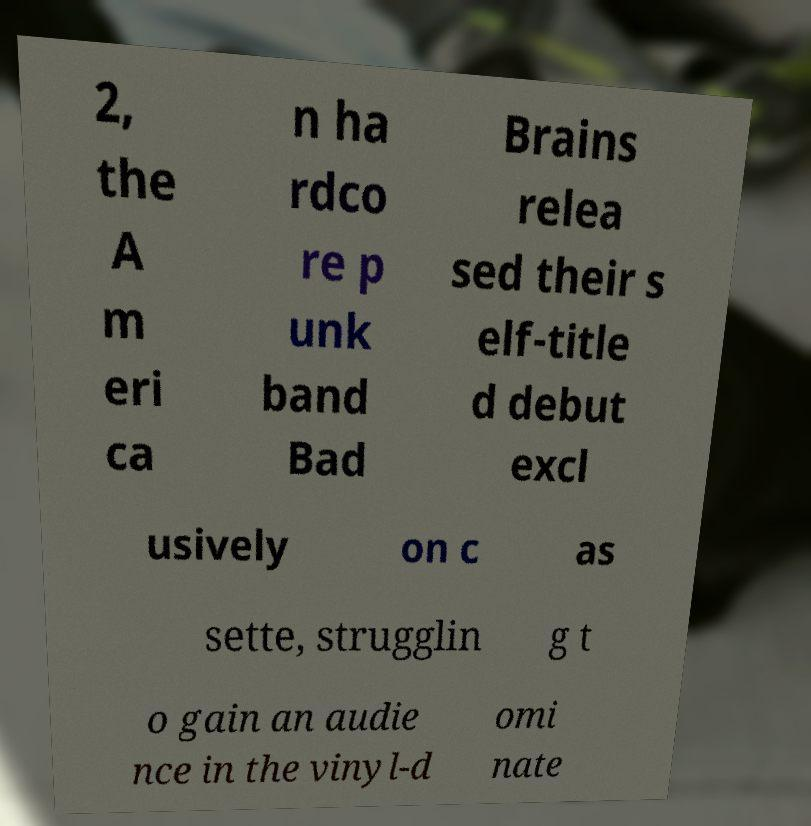Could you assist in decoding the text presented in this image and type it out clearly? 2, the A m eri ca n ha rdco re p unk band Bad Brains relea sed their s elf-title d debut excl usively on c as sette, strugglin g t o gain an audie nce in the vinyl-d omi nate 